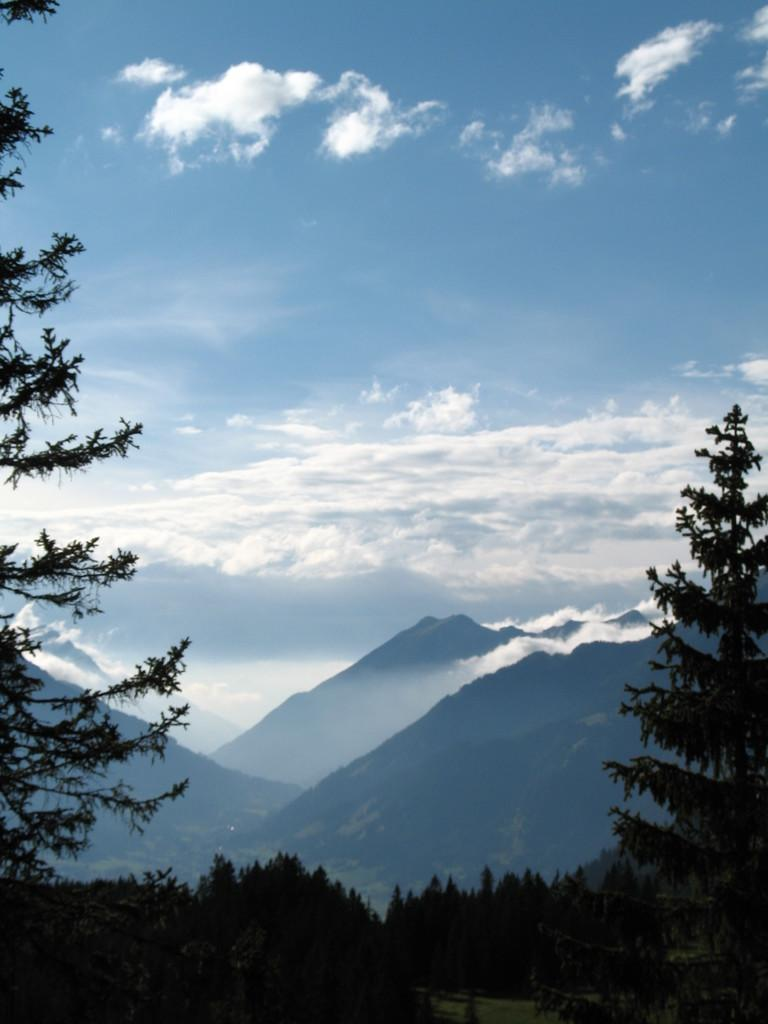What type of vegetation is in the foreground of the image? There are trees in the foreground of the image. What type of natural formation can be seen in the background of the image? There are mountains in the background of the image. What else is visible in the background of the image? The sky is visible in the background of the image. What can be observed in the sky? There are clouds in the sky. Can you tell me how many chess pieces are on the ground in the image? There are no chess pieces present in the image. Is there a pipe visible in the image? There is no pipe visible in the image. 